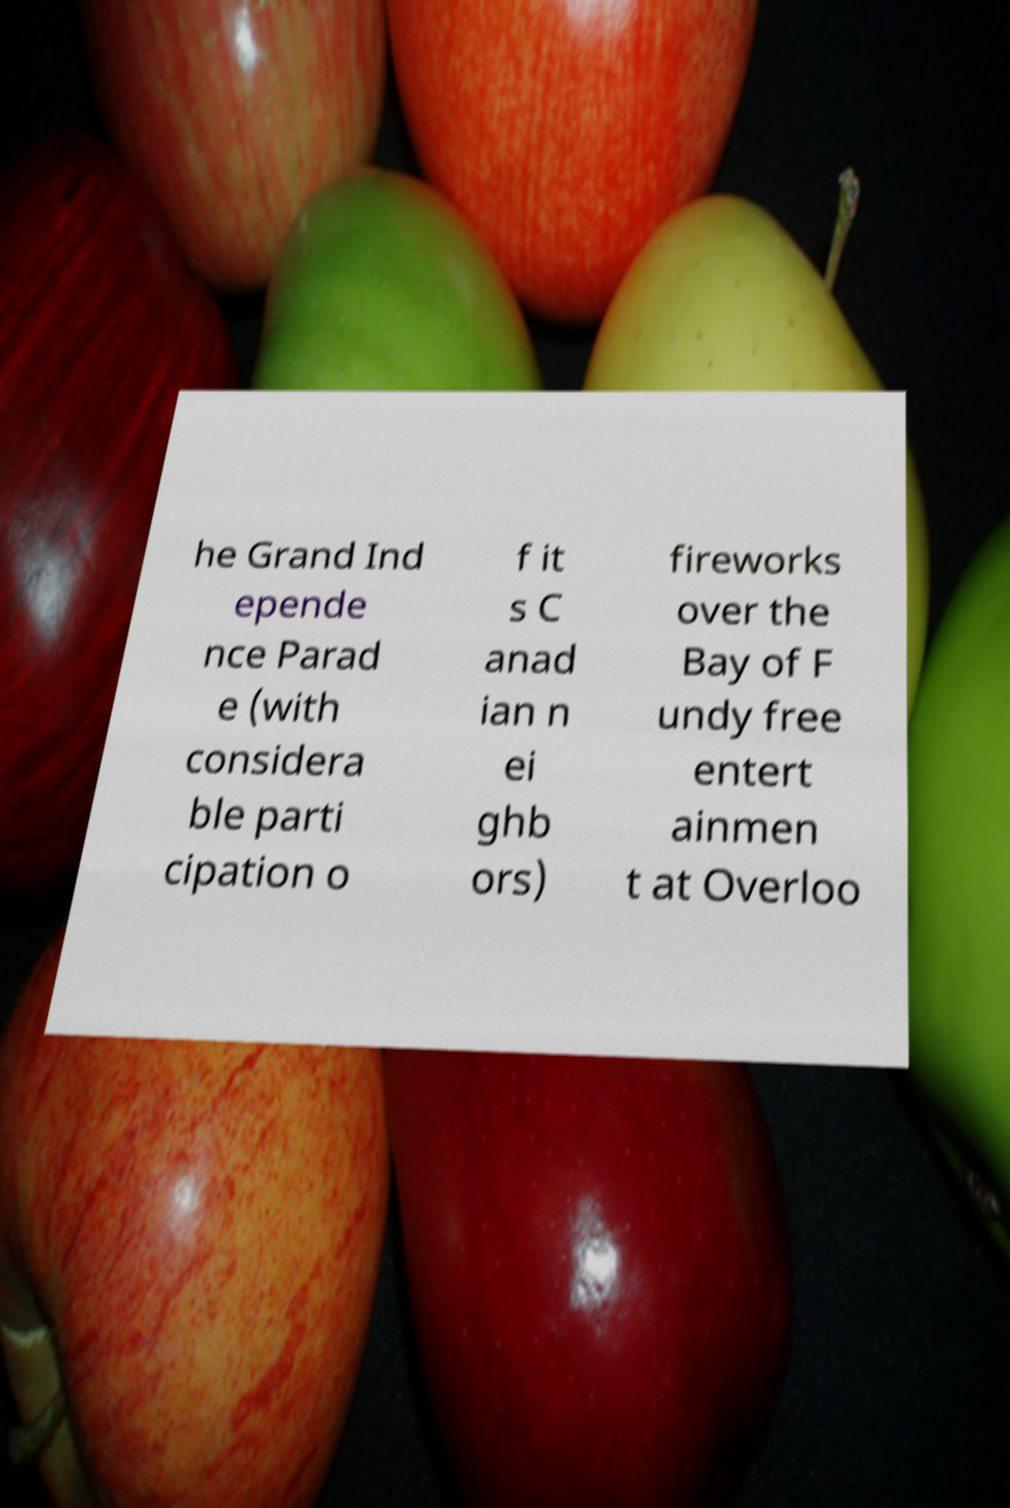Could you assist in decoding the text presented in this image and type it out clearly? he Grand Ind epende nce Parad e (with considera ble parti cipation o f it s C anad ian n ei ghb ors) fireworks over the Bay of F undy free entert ainmen t at Overloo 